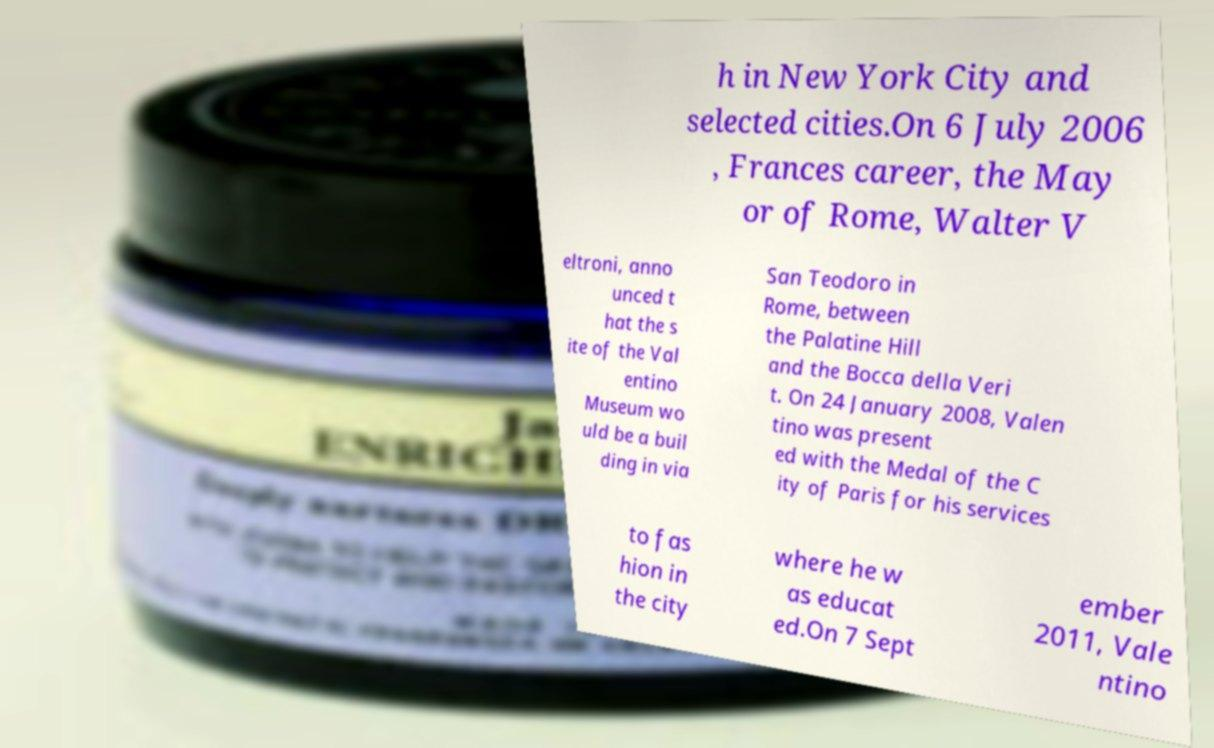Could you extract and type out the text from this image? h in New York City and selected cities.On 6 July 2006 , Frances career, the May or of Rome, Walter V eltroni, anno unced t hat the s ite of the Val entino Museum wo uld be a buil ding in via San Teodoro in Rome, between the Palatine Hill and the Bocca della Veri t. On 24 January 2008, Valen tino was present ed with the Medal of the C ity of Paris for his services to fas hion in the city where he w as educat ed.On 7 Sept ember 2011, Vale ntino 